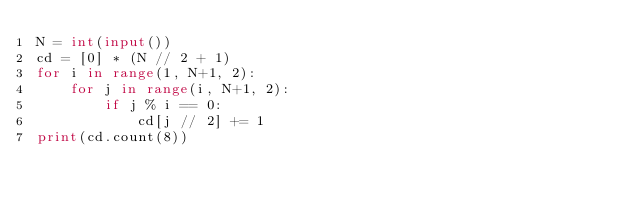<code> <loc_0><loc_0><loc_500><loc_500><_Python_>N = int(input())
cd = [0] * (N // 2 + 1)
for i in range(1, N+1, 2):
    for j in range(i, N+1, 2):
        if j % i == 0:
            cd[j // 2] += 1
print(cd.count(8))
</code> 